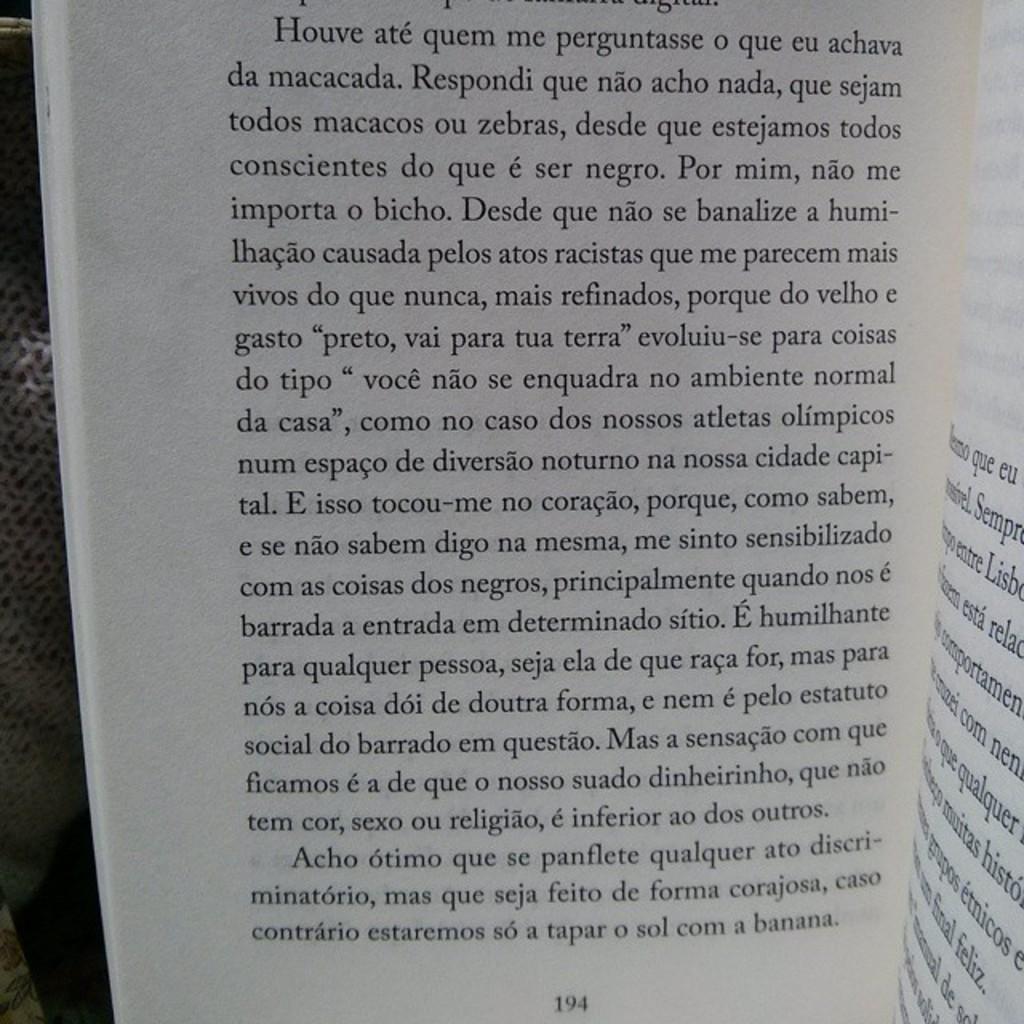What is depicted in the image? There are pages of a book in the image. Can you describe the pages in more detail? Unfortunately, the provided facts do not offer any additional details about the pages. Is there any context or setting provided for the book pages? No, the image only shows the pages of a book, and no context or setting is provided. Where is the truck parked in relation to the book pages in the image? There is no truck present in the image; it only shows the pages of a book. 